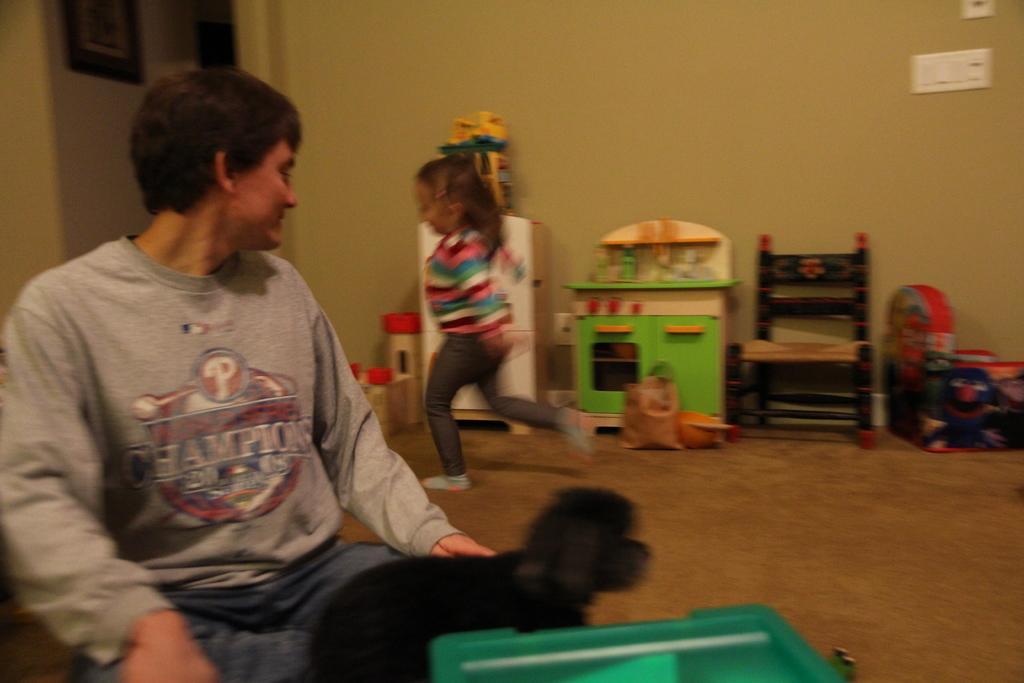How would you summarize this image in a sentence or two? On the left side, there is a person in gray color T-shirt, sitting. Beside him, there is a black color animal. In the background, there is a child running on the floor, there is a chair, there are toys and there is a wall. 